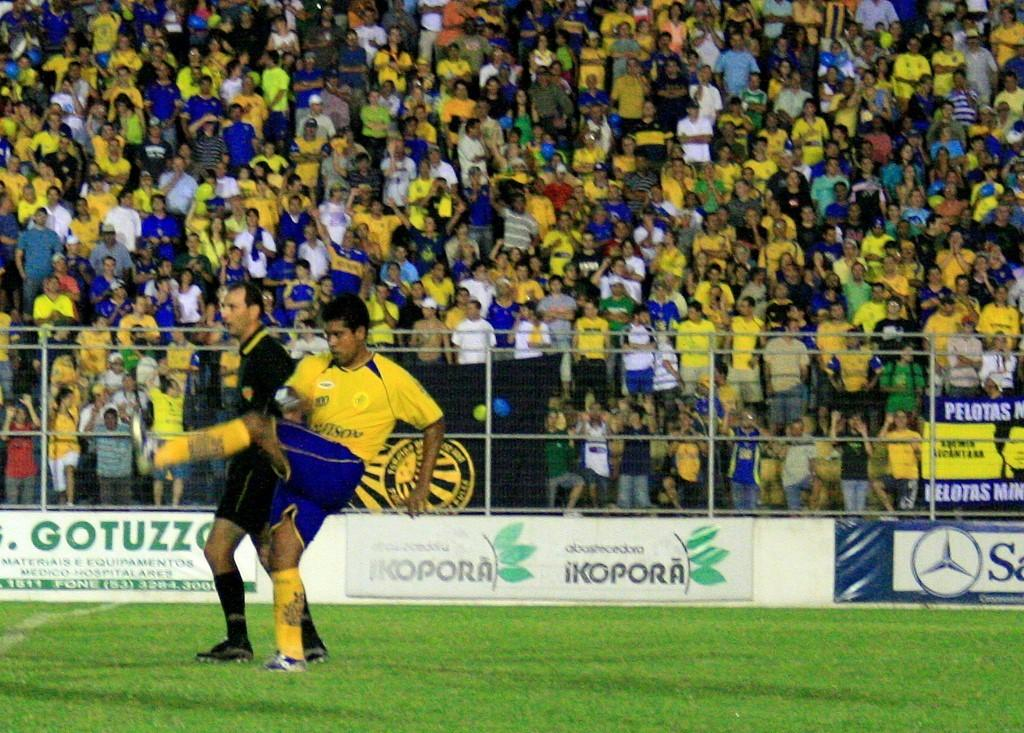<image>
Describe the image concisely. Soccer player on a field with an ad that says "iKopora". 